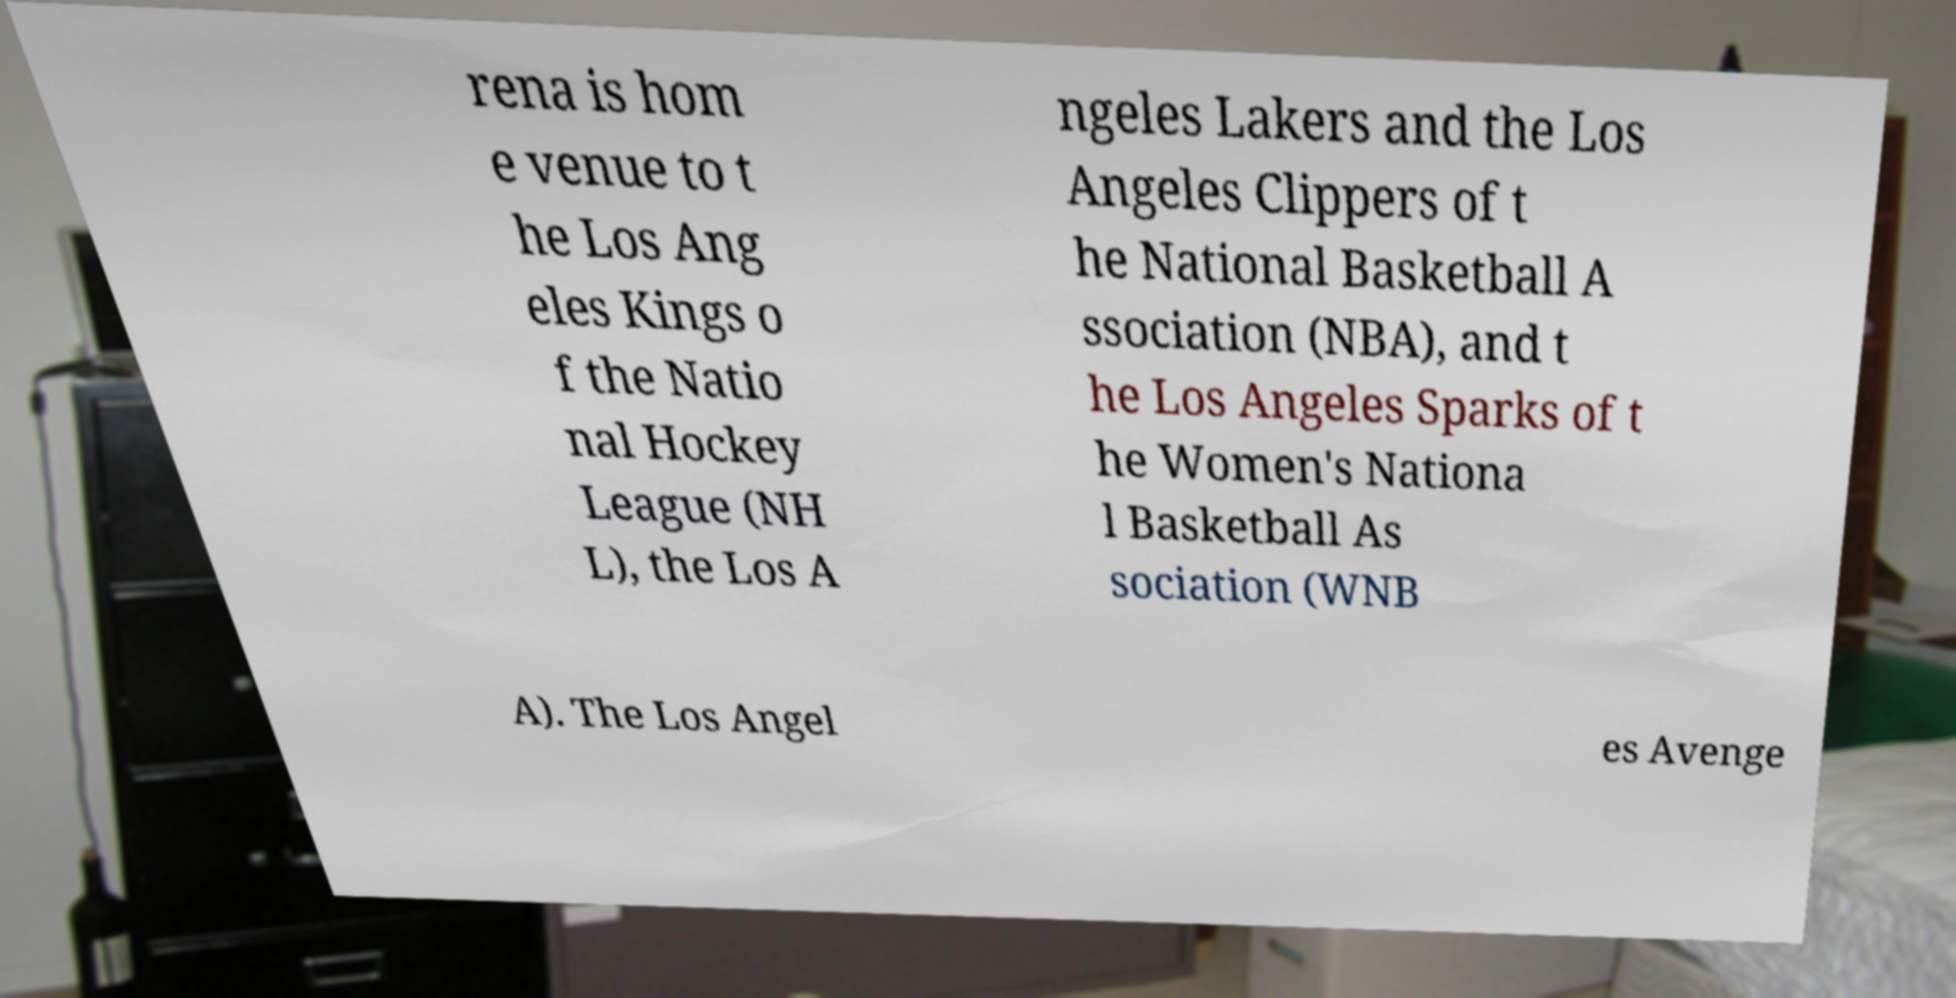Can you read and provide the text displayed in the image?This photo seems to have some interesting text. Can you extract and type it out for me? rena is hom e venue to t he Los Ang eles Kings o f the Natio nal Hockey League (NH L), the Los A ngeles Lakers and the Los Angeles Clippers of t he National Basketball A ssociation (NBA), and t he Los Angeles Sparks of t he Women's Nationa l Basketball As sociation (WNB A). The Los Angel es Avenge 